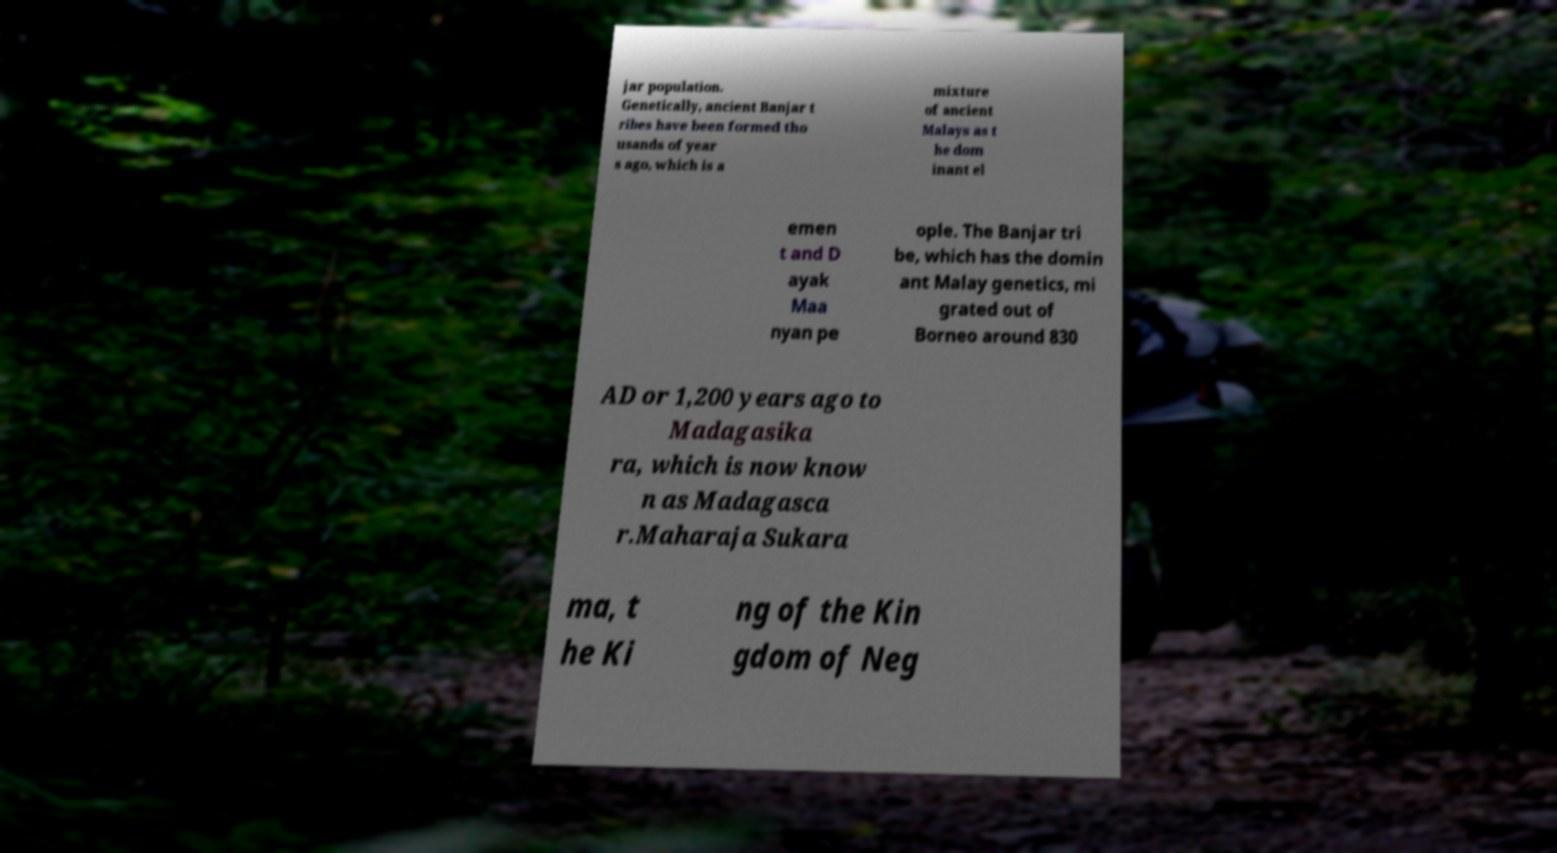Could you extract and type out the text from this image? jar population. Genetically, ancient Banjar t ribes have been formed tho usands of year s ago, which is a mixture of ancient Malays as t he dom inant el emen t and D ayak Maa nyan pe ople. The Banjar tri be, which has the domin ant Malay genetics, mi grated out of Borneo around 830 AD or 1,200 years ago to Madagasika ra, which is now know n as Madagasca r.Maharaja Sukara ma, t he Ki ng of the Kin gdom of Neg 